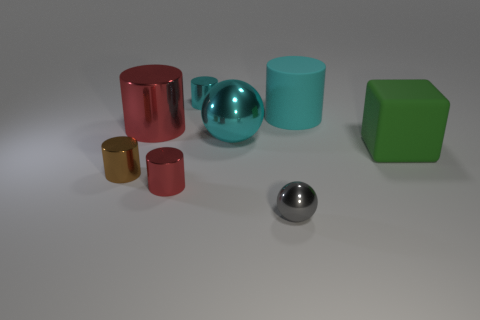What shape is the tiny metal thing to the left of the large red cylinder?
Ensure brevity in your answer.  Cylinder. How many green rubber objects have the same shape as the small red shiny thing?
Provide a short and direct response. 0. There is a ball that is left of the metallic ball in front of the tiny brown thing; what is its size?
Make the answer very short. Large. What number of gray objects are small shiny objects or balls?
Keep it short and to the point. 1. Are there fewer cyan rubber cylinders on the left side of the tiny metal ball than tiny metallic balls that are on the left side of the brown cylinder?
Your response must be concise. No. Do the gray object and the red thing that is on the left side of the tiny red metallic cylinder have the same size?
Your answer should be compact. No. What number of cyan shiny things are the same size as the brown cylinder?
Give a very brief answer. 1. What number of small things are either gray metal spheres or purple objects?
Offer a terse response. 1. Is there a big green sphere?
Keep it short and to the point. No. Are there more big green matte objects left of the big red cylinder than rubber objects on the left side of the large cyan matte cylinder?
Ensure brevity in your answer.  No. 